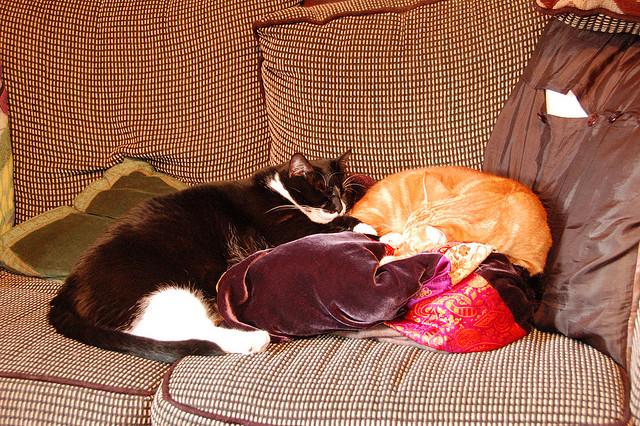What color trim is on the seat cushions?
Keep it brief. Brown. What is the cat laying on?
Concise answer only. Pillow. Is the cat asleep?
Concise answer only. Yes. 